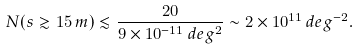<formula> <loc_0><loc_0><loc_500><loc_500>N ( s \gtrsim 1 5 \, m ) \lesssim \frac { 2 0 } { 9 \times 1 0 ^ { - 1 1 } \, d e g ^ { 2 } } \sim 2 \times 1 0 ^ { 1 1 } \, d e g ^ { - 2 } .</formula> 